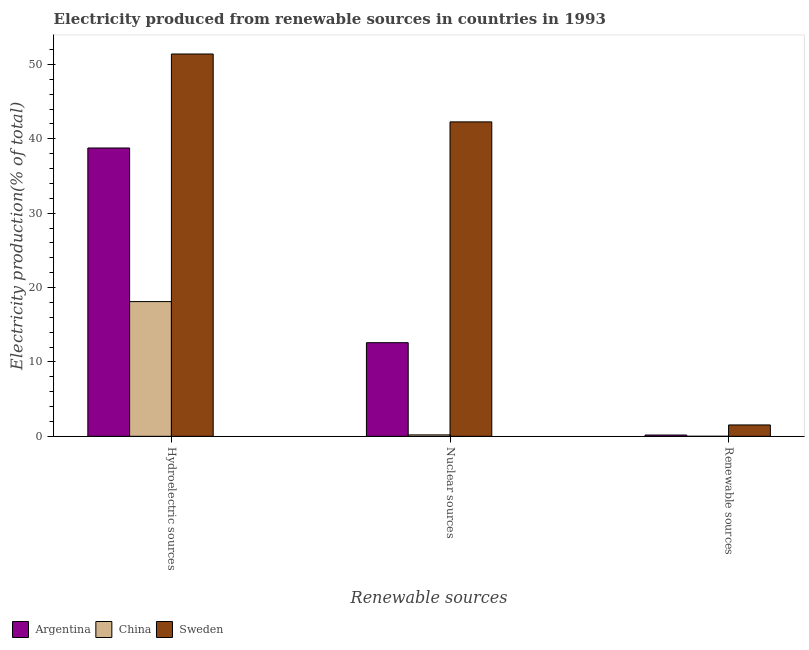Are the number of bars per tick equal to the number of legend labels?
Provide a succinct answer. Yes. Are the number of bars on each tick of the X-axis equal?
Offer a terse response. Yes. What is the label of the 1st group of bars from the left?
Give a very brief answer. Hydroelectric sources. What is the percentage of electricity produced by nuclear sources in China?
Offer a terse response. 0.19. Across all countries, what is the maximum percentage of electricity produced by renewable sources?
Give a very brief answer. 1.53. Across all countries, what is the minimum percentage of electricity produced by hydroelectric sources?
Provide a short and direct response. 18.11. What is the total percentage of electricity produced by nuclear sources in the graph?
Your answer should be very brief. 55.05. What is the difference between the percentage of electricity produced by nuclear sources in China and that in Argentina?
Provide a short and direct response. -12.39. What is the difference between the percentage of electricity produced by renewable sources in Sweden and the percentage of electricity produced by hydroelectric sources in China?
Keep it short and to the point. -16.58. What is the average percentage of electricity produced by renewable sources per country?
Make the answer very short. 0.57. What is the difference between the percentage of electricity produced by renewable sources and percentage of electricity produced by nuclear sources in China?
Ensure brevity in your answer.  -0.19. What is the ratio of the percentage of electricity produced by hydroelectric sources in Argentina to that in China?
Make the answer very short. 2.14. Is the percentage of electricity produced by nuclear sources in Sweden less than that in Argentina?
Keep it short and to the point. No. Is the difference between the percentage of electricity produced by nuclear sources in Sweden and Argentina greater than the difference between the percentage of electricity produced by hydroelectric sources in Sweden and Argentina?
Provide a short and direct response. Yes. What is the difference between the highest and the second highest percentage of electricity produced by renewable sources?
Ensure brevity in your answer.  1.35. What is the difference between the highest and the lowest percentage of electricity produced by renewable sources?
Offer a very short reply. 1.53. In how many countries, is the percentage of electricity produced by renewable sources greater than the average percentage of electricity produced by renewable sources taken over all countries?
Provide a short and direct response. 1. How many bars are there?
Your response must be concise. 9. How many countries are there in the graph?
Keep it short and to the point. 3. Are the values on the major ticks of Y-axis written in scientific E-notation?
Keep it short and to the point. No. Does the graph contain any zero values?
Offer a terse response. No. How many legend labels are there?
Your response must be concise. 3. What is the title of the graph?
Your response must be concise. Electricity produced from renewable sources in countries in 1993. Does "St. Kitts and Nevis" appear as one of the legend labels in the graph?
Your response must be concise. No. What is the label or title of the X-axis?
Offer a very short reply. Renewable sources. What is the label or title of the Y-axis?
Your answer should be compact. Electricity production(% of total). What is the Electricity production(% of total) in Argentina in Hydroelectric sources?
Offer a very short reply. 38.76. What is the Electricity production(% of total) in China in Hydroelectric sources?
Ensure brevity in your answer.  18.11. What is the Electricity production(% of total) in Sweden in Hydroelectric sources?
Ensure brevity in your answer.  51.4. What is the Electricity production(% of total) in Argentina in Nuclear sources?
Keep it short and to the point. 12.59. What is the Electricity production(% of total) in China in Nuclear sources?
Provide a succinct answer. 0.19. What is the Electricity production(% of total) in Sweden in Nuclear sources?
Give a very brief answer. 42.27. What is the Electricity production(% of total) of Argentina in Renewable sources?
Your answer should be compact. 0.17. What is the Electricity production(% of total) of China in Renewable sources?
Your answer should be very brief. 0. What is the Electricity production(% of total) in Sweden in Renewable sources?
Your answer should be compact. 1.53. Across all Renewable sources, what is the maximum Electricity production(% of total) of Argentina?
Provide a short and direct response. 38.76. Across all Renewable sources, what is the maximum Electricity production(% of total) in China?
Keep it short and to the point. 18.11. Across all Renewable sources, what is the maximum Electricity production(% of total) in Sweden?
Offer a terse response. 51.4. Across all Renewable sources, what is the minimum Electricity production(% of total) in Argentina?
Give a very brief answer. 0.17. Across all Renewable sources, what is the minimum Electricity production(% of total) in China?
Offer a terse response. 0. Across all Renewable sources, what is the minimum Electricity production(% of total) in Sweden?
Give a very brief answer. 1.53. What is the total Electricity production(% of total) of Argentina in the graph?
Ensure brevity in your answer.  51.52. What is the total Electricity production(% of total) of China in the graph?
Your answer should be very brief. 18.31. What is the total Electricity production(% of total) of Sweden in the graph?
Give a very brief answer. 95.19. What is the difference between the Electricity production(% of total) in Argentina in Hydroelectric sources and that in Nuclear sources?
Your answer should be compact. 26.17. What is the difference between the Electricity production(% of total) of China in Hydroelectric sources and that in Nuclear sources?
Offer a very short reply. 17.92. What is the difference between the Electricity production(% of total) in Sweden in Hydroelectric sources and that in Nuclear sources?
Offer a very short reply. 9.13. What is the difference between the Electricity production(% of total) of Argentina in Hydroelectric sources and that in Renewable sources?
Offer a terse response. 38.59. What is the difference between the Electricity production(% of total) in China in Hydroelectric sources and that in Renewable sources?
Ensure brevity in your answer.  18.11. What is the difference between the Electricity production(% of total) in Sweden in Hydroelectric sources and that in Renewable sources?
Offer a terse response. 49.87. What is the difference between the Electricity production(% of total) in Argentina in Nuclear sources and that in Renewable sources?
Make the answer very short. 12.41. What is the difference between the Electricity production(% of total) in China in Nuclear sources and that in Renewable sources?
Your response must be concise. 0.19. What is the difference between the Electricity production(% of total) in Sweden in Nuclear sources and that in Renewable sources?
Ensure brevity in your answer.  40.74. What is the difference between the Electricity production(% of total) in Argentina in Hydroelectric sources and the Electricity production(% of total) in China in Nuclear sources?
Provide a succinct answer. 38.57. What is the difference between the Electricity production(% of total) in Argentina in Hydroelectric sources and the Electricity production(% of total) in Sweden in Nuclear sources?
Your response must be concise. -3.51. What is the difference between the Electricity production(% of total) of China in Hydroelectric sources and the Electricity production(% of total) of Sweden in Nuclear sources?
Provide a short and direct response. -24.16. What is the difference between the Electricity production(% of total) of Argentina in Hydroelectric sources and the Electricity production(% of total) of China in Renewable sources?
Your answer should be compact. 38.76. What is the difference between the Electricity production(% of total) of Argentina in Hydroelectric sources and the Electricity production(% of total) of Sweden in Renewable sources?
Give a very brief answer. 37.23. What is the difference between the Electricity production(% of total) in China in Hydroelectric sources and the Electricity production(% of total) in Sweden in Renewable sources?
Give a very brief answer. 16.58. What is the difference between the Electricity production(% of total) of Argentina in Nuclear sources and the Electricity production(% of total) of China in Renewable sources?
Your response must be concise. 12.58. What is the difference between the Electricity production(% of total) in Argentina in Nuclear sources and the Electricity production(% of total) in Sweden in Renewable sources?
Give a very brief answer. 11.06. What is the difference between the Electricity production(% of total) in China in Nuclear sources and the Electricity production(% of total) in Sweden in Renewable sources?
Make the answer very short. -1.34. What is the average Electricity production(% of total) in Argentina per Renewable sources?
Offer a very short reply. 17.17. What is the average Electricity production(% of total) in China per Renewable sources?
Make the answer very short. 6.1. What is the average Electricity production(% of total) in Sweden per Renewable sources?
Provide a succinct answer. 31.73. What is the difference between the Electricity production(% of total) of Argentina and Electricity production(% of total) of China in Hydroelectric sources?
Your answer should be compact. 20.65. What is the difference between the Electricity production(% of total) of Argentina and Electricity production(% of total) of Sweden in Hydroelectric sources?
Keep it short and to the point. -12.64. What is the difference between the Electricity production(% of total) of China and Electricity production(% of total) of Sweden in Hydroelectric sources?
Your answer should be very brief. -33.29. What is the difference between the Electricity production(% of total) in Argentina and Electricity production(% of total) in China in Nuclear sources?
Offer a very short reply. 12.39. What is the difference between the Electricity production(% of total) in Argentina and Electricity production(% of total) in Sweden in Nuclear sources?
Give a very brief answer. -29.68. What is the difference between the Electricity production(% of total) in China and Electricity production(% of total) in Sweden in Nuclear sources?
Provide a succinct answer. -42.08. What is the difference between the Electricity production(% of total) in Argentina and Electricity production(% of total) in China in Renewable sources?
Ensure brevity in your answer.  0.17. What is the difference between the Electricity production(% of total) in Argentina and Electricity production(% of total) in Sweden in Renewable sources?
Give a very brief answer. -1.35. What is the difference between the Electricity production(% of total) in China and Electricity production(% of total) in Sweden in Renewable sources?
Make the answer very short. -1.53. What is the ratio of the Electricity production(% of total) of Argentina in Hydroelectric sources to that in Nuclear sources?
Ensure brevity in your answer.  3.08. What is the ratio of the Electricity production(% of total) of China in Hydroelectric sources to that in Nuclear sources?
Provide a short and direct response. 94.65. What is the ratio of the Electricity production(% of total) in Sweden in Hydroelectric sources to that in Nuclear sources?
Give a very brief answer. 1.22. What is the ratio of the Electricity production(% of total) of Argentina in Hydroelectric sources to that in Renewable sources?
Your answer should be very brief. 223.06. What is the ratio of the Electricity production(% of total) in China in Hydroelectric sources to that in Renewable sources?
Provide a succinct answer. 5839.19. What is the ratio of the Electricity production(% of total) of Sweden in Hydroelectric sources to that in Renewable sources?
Provide a succinct answer. 33.63. What is the ratio of the Electricity production(% of total) in Argentina in Nuclear sources to that in Renewable sources?
Offer a very short reply. 72.43. What is the ratio of the Electricity production(% of total) of China in Nuclear sources to that in Renewable sources?
Provide a succinct answer. 61.69. What is the ratio of the Electricity production(% of total) in Sweden in Nuclear sources to that in Renewable sources?
Provide a succinct answer. 27.66. What is the difference between the highest and the second highest Electricity production(% of total) in Argentina?
Offer a very short reply. 26.17. What is the difference between the highest and the second highest Electricity production(% of total) in China?
Your answer should be compact. 17.92. What is the difference between the highest and the second highest Electricity production(% of total) of Sweden?
Provide a short and direct response. 9.13. What is the difference between the highest and the lowest Electricity production(% of total) in Argentina?
Provide a short and direct response. 38.59. What is the difference between the highest and the lowest Electricity production(% of total) of China?
Your answer should be very brief. 18.11. What is the difference between the highest and the lowest Electricity production(% of total) in Sweden?
Your answer should be very brief. 49.87. 